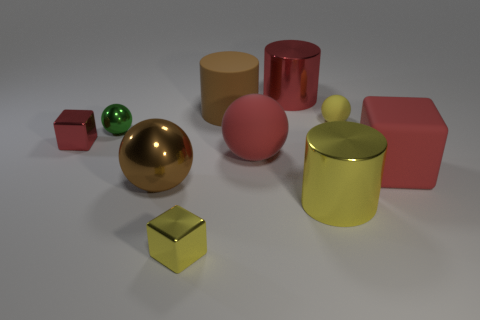Subtract 1 cubes. How many cubes are left? 2 Subtract all cyan spheres. Subtract all red blocks. How many spheres are left? 4 Subtract all cubes. How many objects are left? 7 Add 6 big rubber cylinders. How many big rubber cylinders are left? 7 Add 2 rubber things. How many rubber things exist? 6 Subtract 0 blue cubes. How many objects are left? 10 Subtract all big brown metallic objects. Subtract all big blue things. How many objects are left? 9 